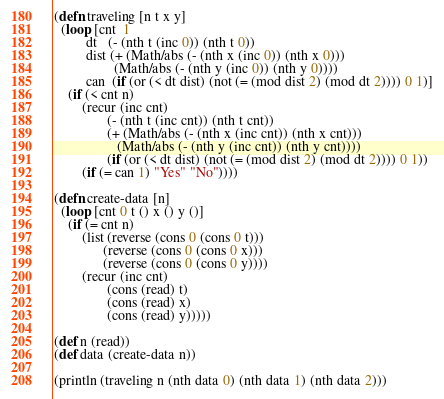Convert code to text. <code><loc_0><loc_0><loc_500><loc_500><_Clojure_>(defn traveling [n t x y]
  (loop [cnt  1
         dt   (- (nth t (inc 0)) (nth t 0))
         dist (+ (Math/abs (- (nth x (inc 0)) (nth x 0)))
                 (Math/abs (- (nth y (inc 0)) (nth y 0))))
         can  (if (or (< dt dist) (not (= (mod dist 2) (mod dt 2)))) 0 1)]
    (if (< cnt n)
        (recur (inc cnt)
               (- (nth t (inc cnt)) (nth t cnt))
               (+ (Math/abs (- (nth x (inc cnt)) (nth x cnt)))
                  (Math/abs (- (nth y (inc cnt)) (nth y cnt))))
               (if (or (< dt dist) (not (= (mod dist 2) (mod dt 2)))) 0 1))
        (if (= can 1) "Yes" "No"))))

(defn create-data [n]
  (loop [cnt 0 t () x () y ()]
    (if (= cnt n)
        (list (reverse (cons 0 (cons 0 t)))
              (reverse (cons 0 (cons 0 x)))
              (reverse (cons 0 (cons 0 y))))
        (recur (inc cnt)
               (cons (read) t)
               (cons (read) x)
               (cons (read) y)))))

(def n (read))
(def data (create-data n))

(println (traveling n (nth data 0) (nth data 1) (nth data 2)))</code> 